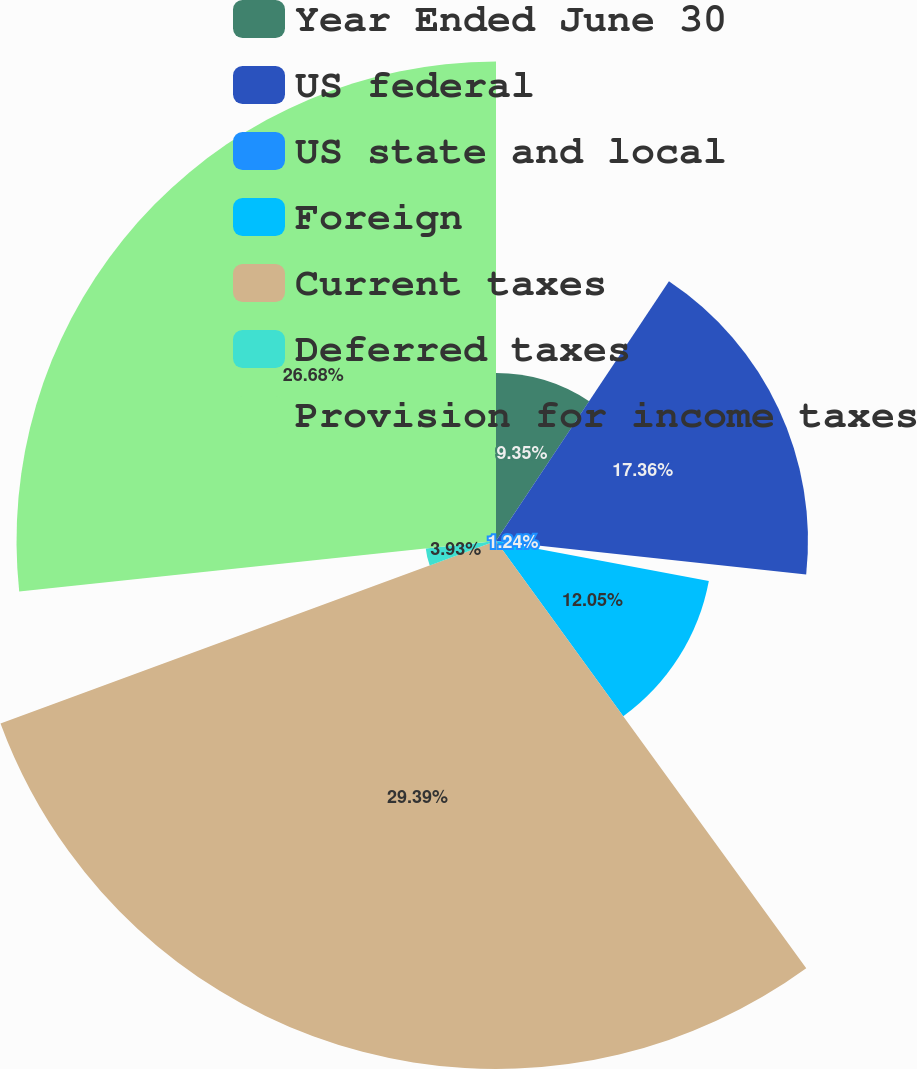Convert chart. <chart><loc_0><loc_0><loc_500><loc_500><pie_chart><fcel>Year Ended June 30<fcel>US federal<fcel>US state and local<fcel>Foreign<fcel>Current taxes<fcel>Deferred taxes<fcel>Provision for income taxes<nl><fcel>9.35%<fcel>17.36%<fcel>1.24%<fcel>12.05%<fcel>29.38%<fcel>3.93%<fcel>26.68%<nl></chart> 